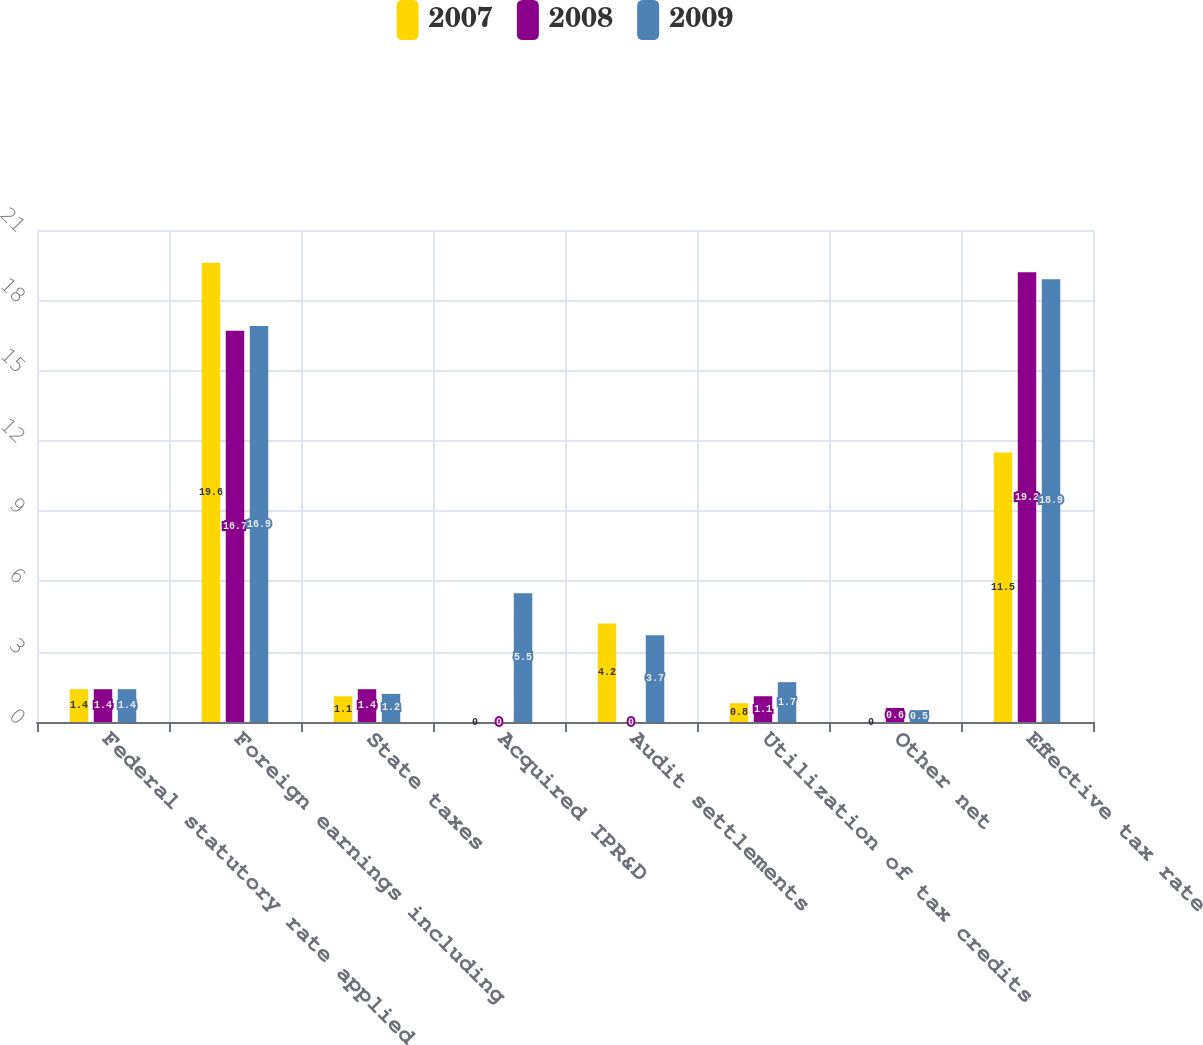Convert chart. <chart><loc_0><loc_0><loc_500><loc_500><stacked_bar_chart><ecel><fcel>Federal statutory rate applied<fcel>Foreign earnings including<fcel>State taxes<fcel>Acquired IPR&D<fcel>Audit settlements<fcel>Utilization of tax credits<fcel>Other net<fcel>Effective tax rate<nl><fcel>2007<fcel>1.4<fcel>19.6<fcel>1.1<fcel>0<fcel>4.2<fcel>0.8<fcel>0<fcel>11.5<nl><fcel>2008<fcel>1.4<fcel>16.7<fcel>1.4<fcel>0<fcel>0<fcel>1.1<fcel>0.6<fcel>19.2<nl><fcel>2009<fcel>1.4<fcel>16.9<fcel>1.2<fcel>5.5<fcel>3.7<fcel>1.7<fcel>0.5<fcel>18.9<nl></chart> 